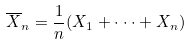<formula> <loc_0><loc_0><loc_500><loc_500>\overline { X } _ { n } = \frac { 1 } { n } ( X _ { 1 } + \cdot \cdot \cdot + X _ { n } )</formula> 